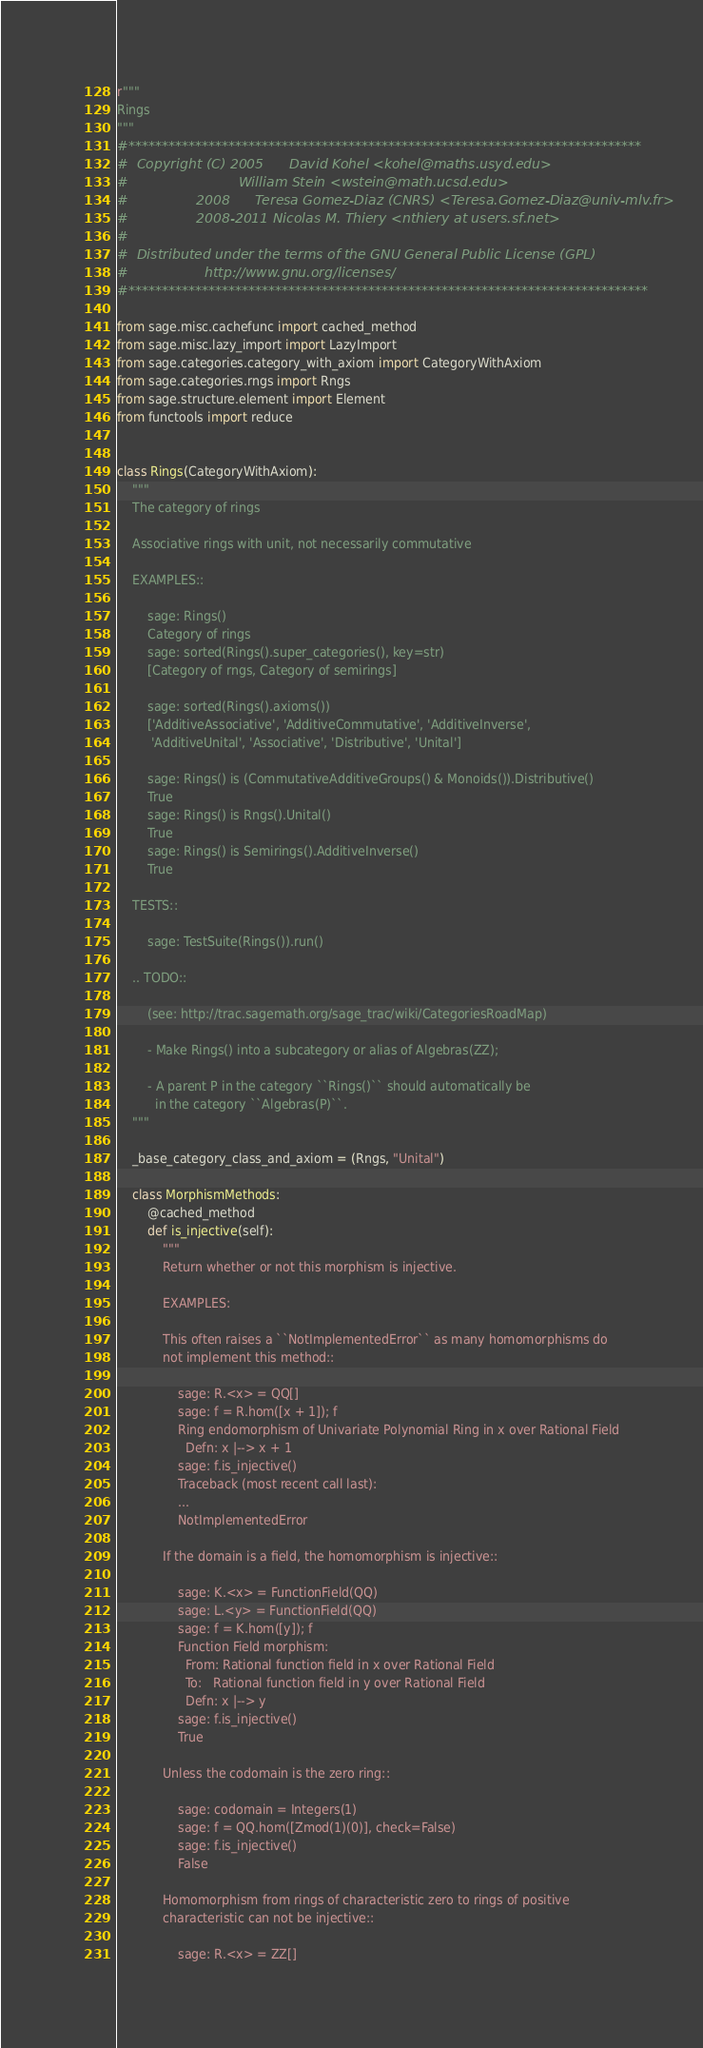Convert code to text. <code><loc_0><loc_0><loc_500><loc_500><_Python_>r"""
Rings
"""
#*****************************************************************************
#  Copyright (C) 2005      David Kohel <kohel@maths.usyd.edu>
#                          William Stein <wstein@math.ucsd.edu>
#                2008      Teresa Gomez-Diaz (CNRS) <Teresa.Gomez-Diaz@univ-mlv.fr>
#                2008-2011 Nicolas M. Thiery <nthiery at users.sf.net>
#
#  Distributed under the terms of the GNU General Public License (GPL)
#                  http://www.gnu.org/licenses/
#******************************************************************************

from sage.misc.cachefunc import cached_method
from sage.misc.lazy_import import LazyImport
from sage.categories.category_with_axiom import CategoryWithAxiom
from sage.categories.rngs import Rngs
from sage.structure.element import Element
from functools import reduce


class Rings(CategoryWithAxiom):
    """
    The category of rings

    Associative rings with unit, not necessarily commutative

    EXAMPLES::

        sage: Rings()
        Category of rings
        sage: sorted(Rings().super_categories(), key=str)
        [Category of rngs, Category of semirings]

        sage: sorted(Rings().axioms())
        ['AdditiveAssociative', 'AdditiveCommutative', 'AdditiveInverse',
         'AdditiveUnital', 'Associative', 'Distributive', 'Unital']

        sage: Rings() is (CommutativeAdditiveGroups() & Monoids()).Distributive()
        True
        sage: Rings() is Rngs().Unital()
        True
        sage: Rings() is Semirings().AdditiveInverse()
        True

    TESTS::

        sage: TestSuite(Rings()).run()

    .. TODO::

        (see: http://trac.sagemath.org/sage_trac/wiki/CategoriesRoadMap)

        - Make Rings() into a subcategory or alias of Algebras(ZZ);

        - A parent P in the category ``Rings()`` should automatically be
          in the category ``Algebras(P)``.
    """

    _base_category_class_and_axiom = (Rngs, "Unital")

    class MorphismMethods:
        @cached_method
        def is_injective(self):
            """
            Return whether or not this morphism is injective.

            EXAMPLES:

            This often raises a ``NotImplementedError`` as many homomorphisms do
            not implement this method::

                sage: R.<x> = QQ[]
                sage: f = R.hom([x + 1]); f
                Ring endomorphism of Univariate Polynomial Ring in x over Rational Field
                  Defn: x |--> x + 1
                sage: f.is_injective()
                Traceback (most recent call last):
                ...
                NotImplementedError

            If the domain is a field, the homomorphism is injective::

                sage: K.<x> = FunctionField(QQ)
                sage: L.<y> = FunctionField(QQ)
                sage: f = K.hom([y]); f
                Function Field morphism:
                  From: Rational function field in x over Rational Field
                  To:   Rational function field in y over Rational Field
                  Defn: x |--> y
                sage: f.is_injective()
                True

            Unless the codomain is the zero ring::

                sage: codomain = Integers(1)
                sage: f = QQ.hom([Zmod(1)(0)], check=False)
                sage: f.is_injective()
                False

            Homomorphism from rings of characteristic zero to rings of positive
            characteristic can not be injective::

                sage: R.<x> = ZZ[]</code> 